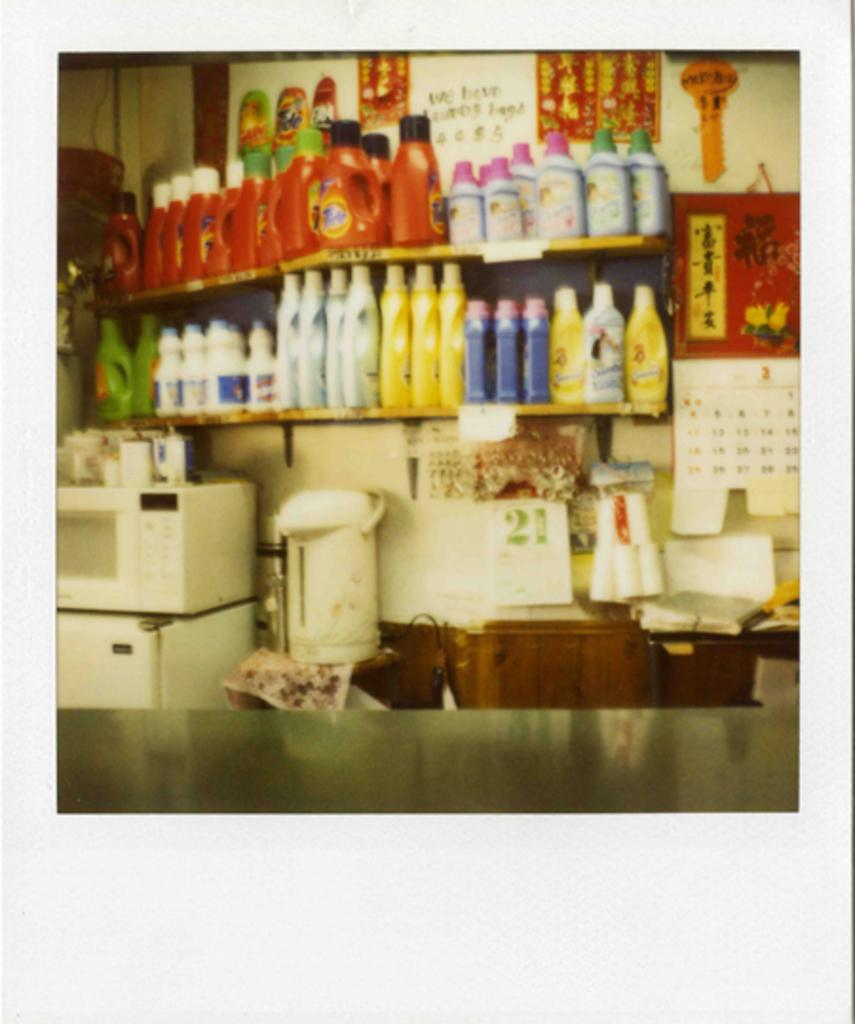<image>
Relay a brief, clear account of the picture shown. the word Tide is on the red item 